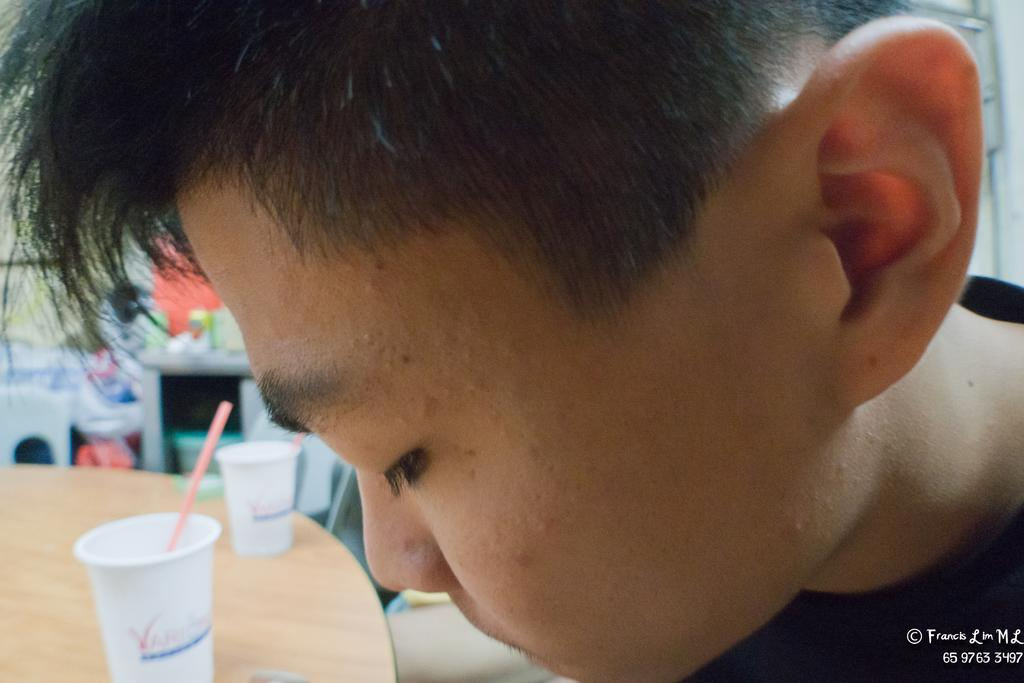What is the main subject in the image? There is a person in the image. Where is the table located in the image? The table is on the left side of the image. What is placed on the table? Glasses are placed on the table. Can you describe the background of the image? There are objects visible in the background of the image. Does the person in the image have a tail? No, the person in the image does not have a tail, as humans do not have tails. 